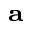<formula> <loc_0><loc_0><loc_500><loc_500>_ { a }</formula> 